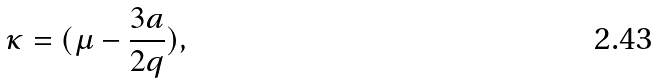<formula> <loc_0><loc_0><loc_500><loc_500>\kappa = ( \mu - \frac { 3 a } { 2 q } ) ,</formula> 